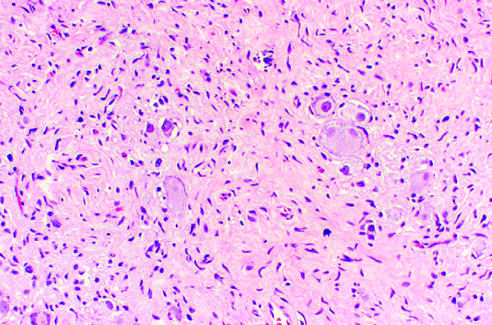re spindle-shaped schwann cells present in the background stroma?
Answer the question using a single word or phrase. Yes 